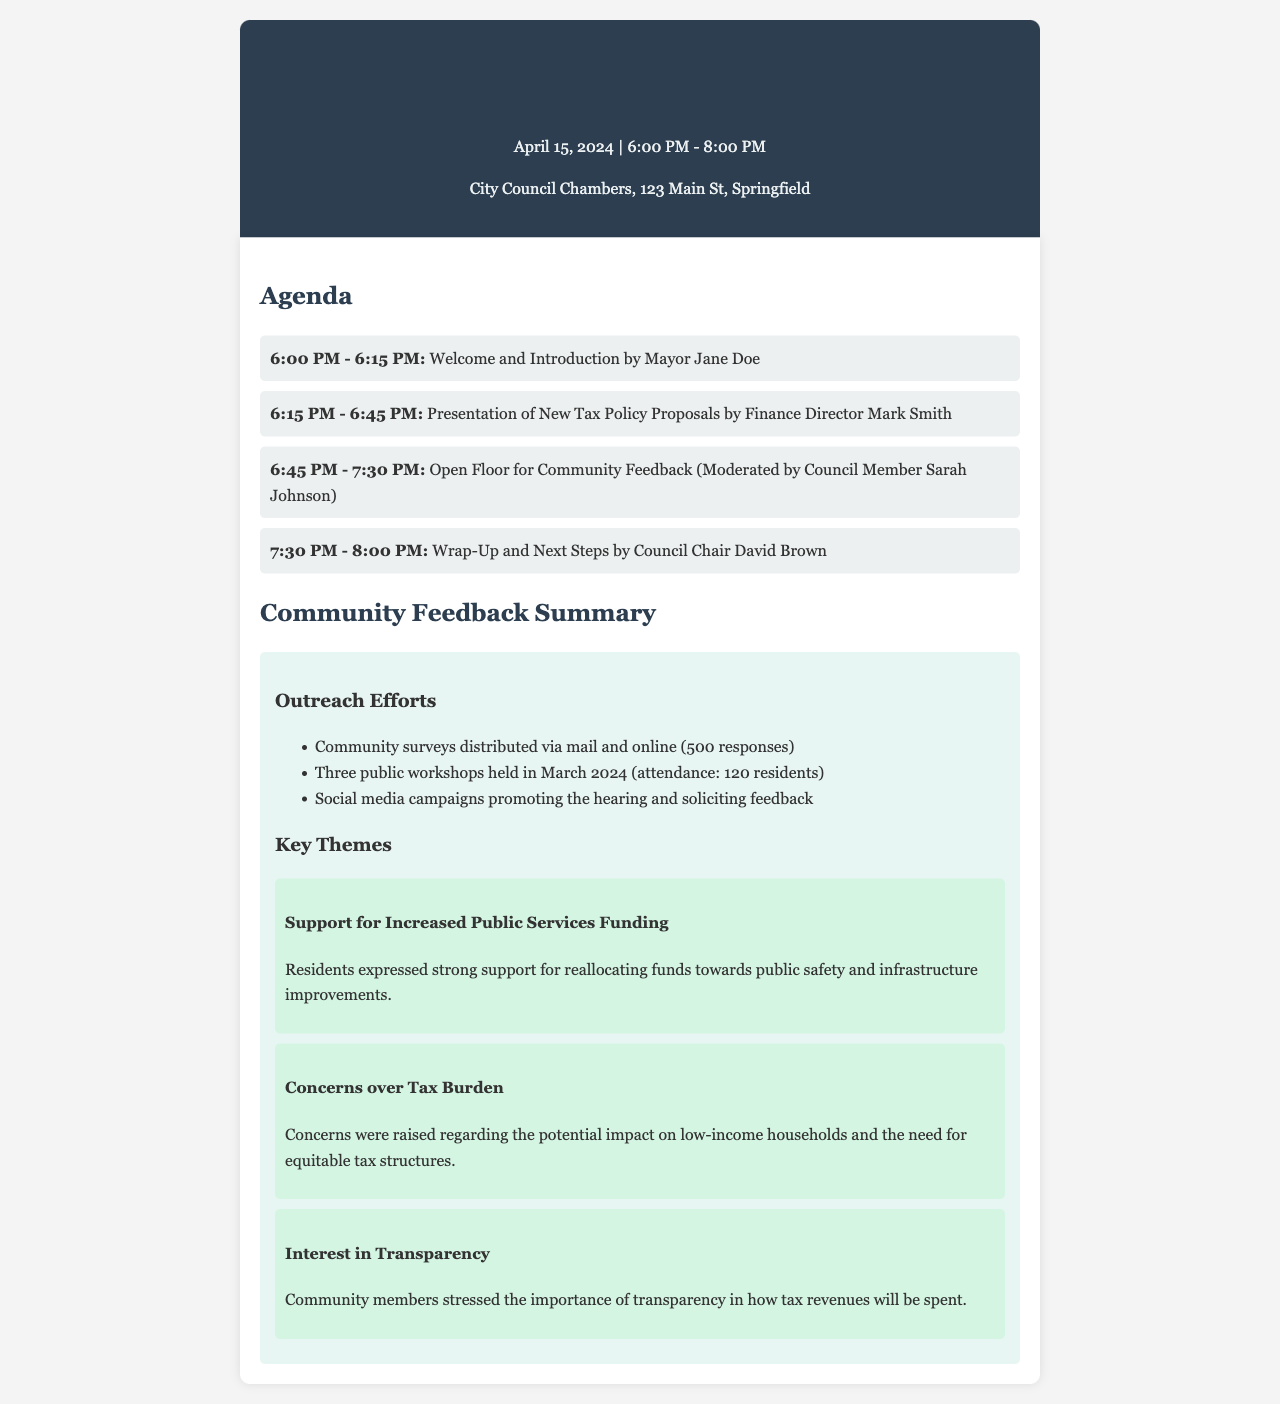What is the date of the public hearing? The date of the public hearing is stated in the header of the document.
Answer: April 15, 2024 Who is presenting the new tax policy proposals? The document specifies the person responsible for the presentation in the agenda section.
Answer: Finance Director Mark Smith What time does the open floor for community feedback start? The starting time for the open floor is detailed in the agenda section of the document.
Answer: 6:45 PM How many responses were received from the community surveys? The document mentions the number of responses received in the community feedback summary.
Answer: 500 responses What was a key theme expressed by the residents regarding public services? The document outlines community feedback and highlights a specific concern in the key themes section.
Answer: Support for Increased Public Services Funding What is one concern raised by residents regarding taxation? The document lists specific concerns in the community feedback summary, specifically under key themes.
Answer: Concerns over Tax Burden How many public workshops were held in March 2024? The number of workshops held is outlined in the outreach efforts section of the community feedback summary.
Answer: Three public workshops Who moderates the community feedback session? The document specifies the moderator for the community feedback session in the agenda section.
Answer: Council Member Sarah Johnson What is the location of the public hearing? The location of the public hearing is mentioned in the header of the document.
Answer: City Council Chambers, 123 Main St, Springfield 